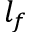<formula> <loc_0><loc_0><loc_500><loc_500>l _ { f }</formula> 